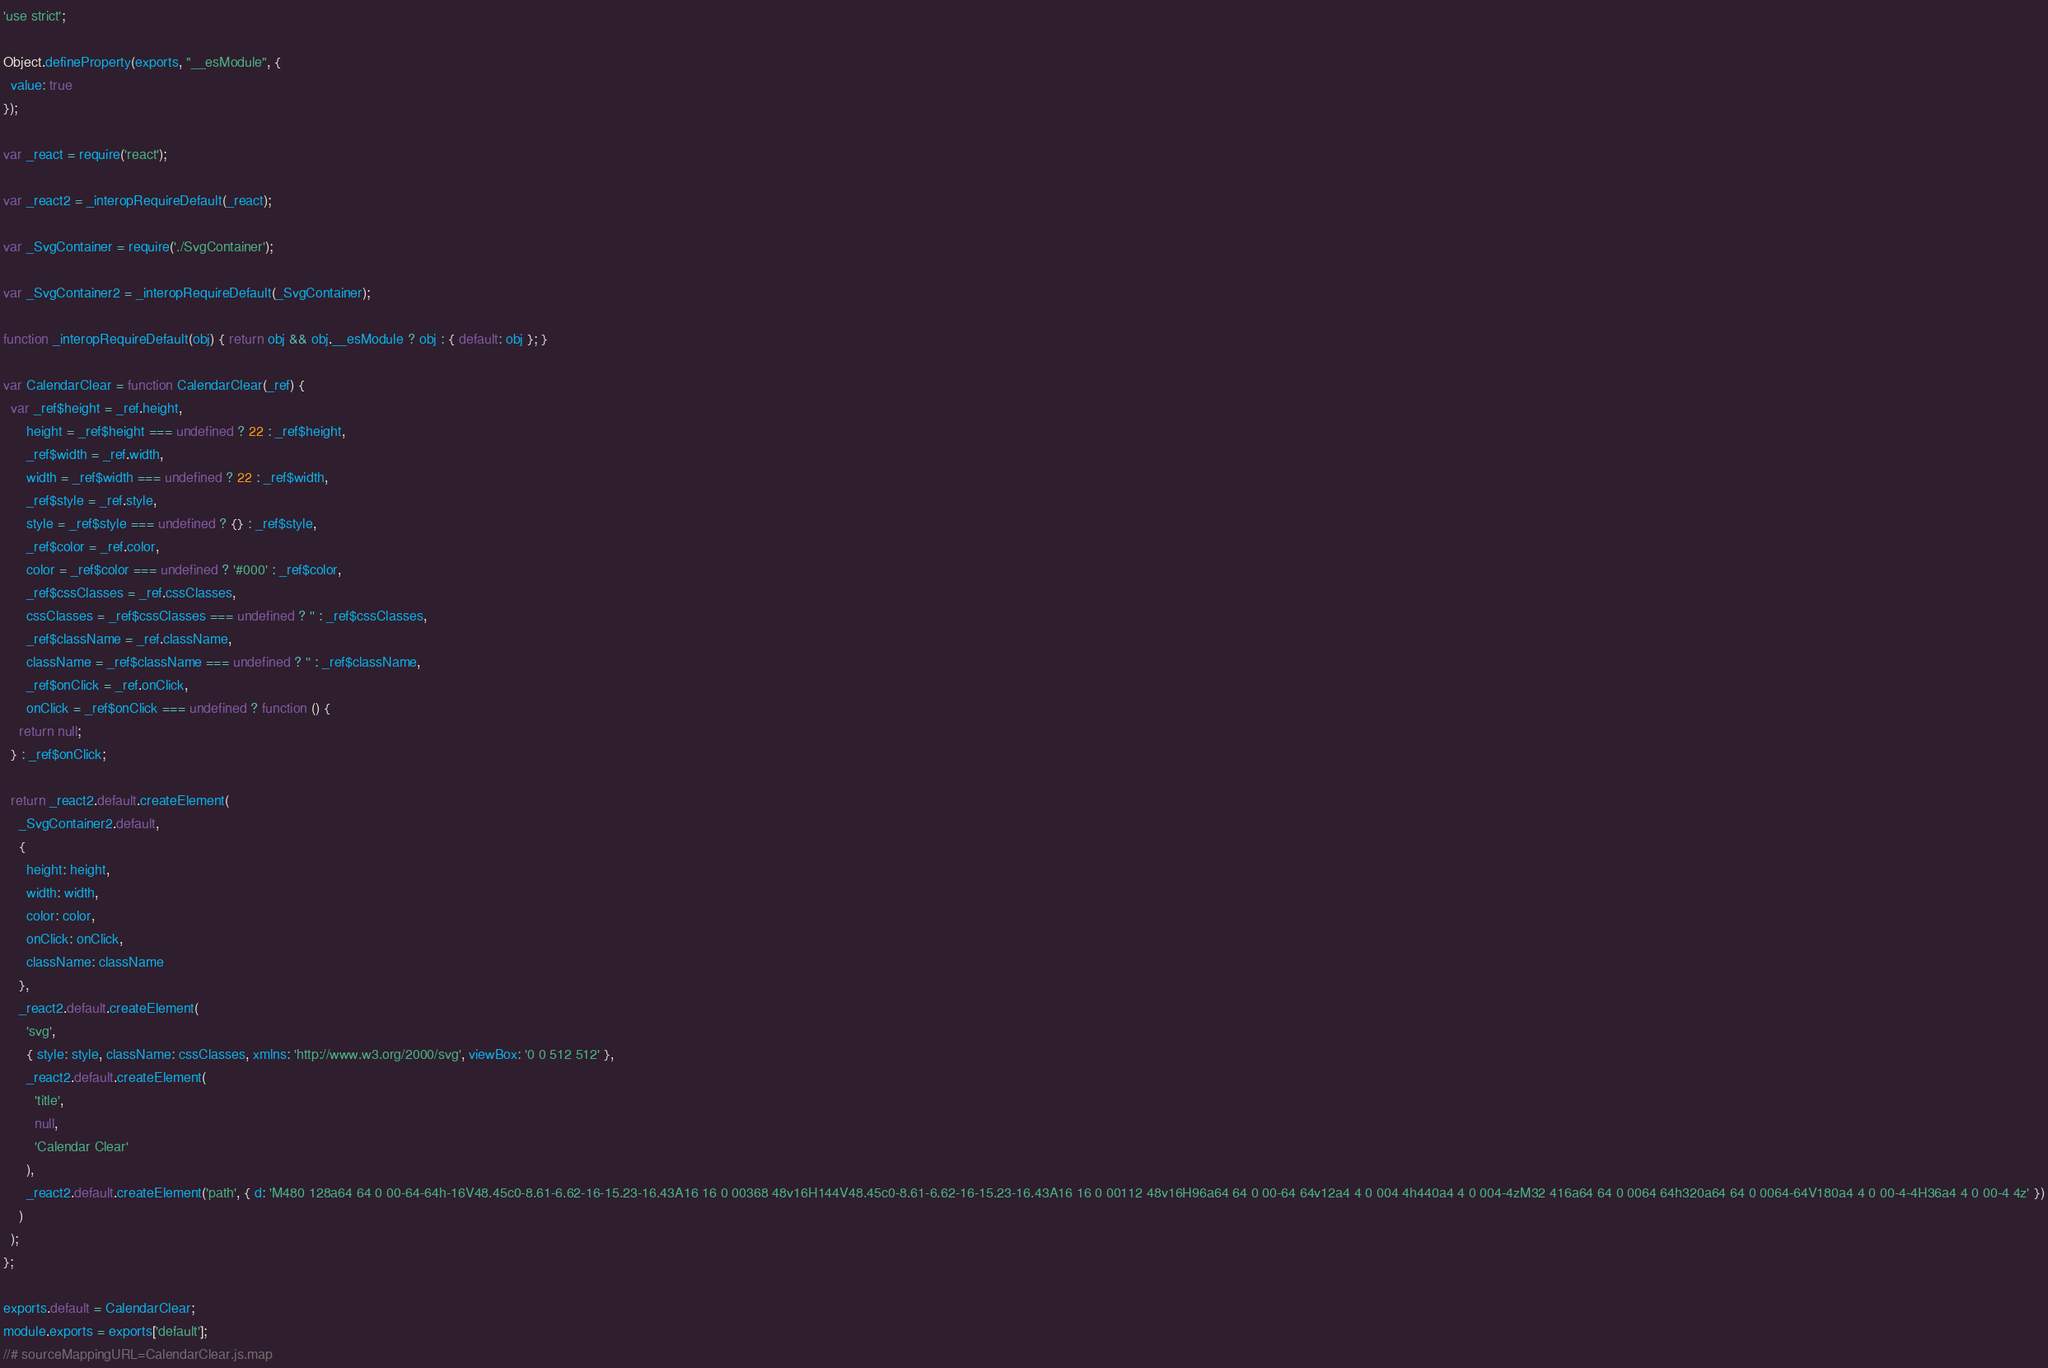<code> <loc_0><loc_0><loc_500><loc_500><_JavaScript_>'use strict';

Object.defineProperty(exports, "__esModule", {
  value: true
});

var _react = require('react');

var _react2 = _interopRequireDefault(_react);

var _SvgContainer = require('./SvgContainer');

var _SvgContainer2 = _interopRequireDefault(_SvgContainer);

function _interopRequireDefault(obj) { return obj && obj.__esModule ? obj : { default: obj }; }

var CalendarClear = function CalendarClear(_ref) {
  var _ref$height = _ref.height,
      height = _ref$height === undefined ? 22 : _ref$height,
      _ref$width = _ref.width,
      width = _ref$width === undefined ? 22 : _ref$width,
      _ref$style = _ref.style,
      style = _ref$style === undefined ? {} : _ref$style,
      _ref$color = _ref.color,
      color = _ref$color === undefined ? '#000' : _ref$color,
      _ref$cssClasses = _ref.cssClasses,
      cssClasses = _ref$cssClasses === undefined ? '' : _ref$cssClasses,
      _ref$className = _ref.className,
      className = _ref$className === undefined ? '' : _ref$className,
      _ref$onClick = _ref.onClick,
      onClick = _ref$onClick === undefined ? function () {
    return null;
  } : _ref$onClick;

  return _react2.default.createElement(
    _SvgContainer2.default,
    {
      height: height,
      width: width,
      color: color,
      onClick: onClick,
      className: className
    },
    _react2.default.createElement(
      'svg',
      { style: style, className: cssClasses, xmlns: 'http://www.w3.org/2000/svg', viewBox: '0 0 512 512' },
      _react2.default.createElement(
        'title',
        null,
        'Calendar Clear'
      ),
      _react2.default.createElement('path', { d: 'M480 128a64 64 0 00-64-64h-16V48.45c0-8.61-6.62-16-15.23-16.43A16 16 0 00368 48v16H144V48.45c0-8.61-6.62-16-15.23-16.43A16 16 0 00112 48v16H96a64 64 0 00-64 64v12a4 4 0 004 4h440a4 4 0 004-4zM32 416a64 64 0 0064 64h320a64 64 0 0064-64V180a4 4 0 00-4-4H36a4 4 0 00-4 4z' })
    )
  );
};

exports.default = CalendarClear;
module.exports = exports['default'];
//# sourceMappingURL=CalendarClear.js.map</code> 